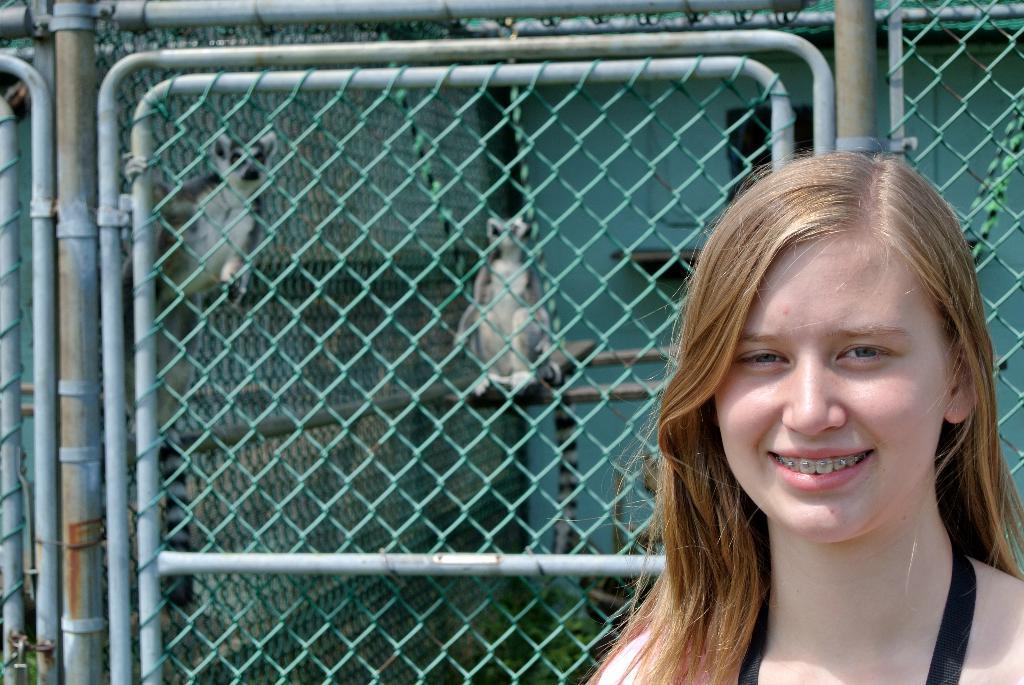How would you summarize this image in a sentence or two? In this image we can see a woman. We can also see a metal fence, a wall and some animals beside the fence. 